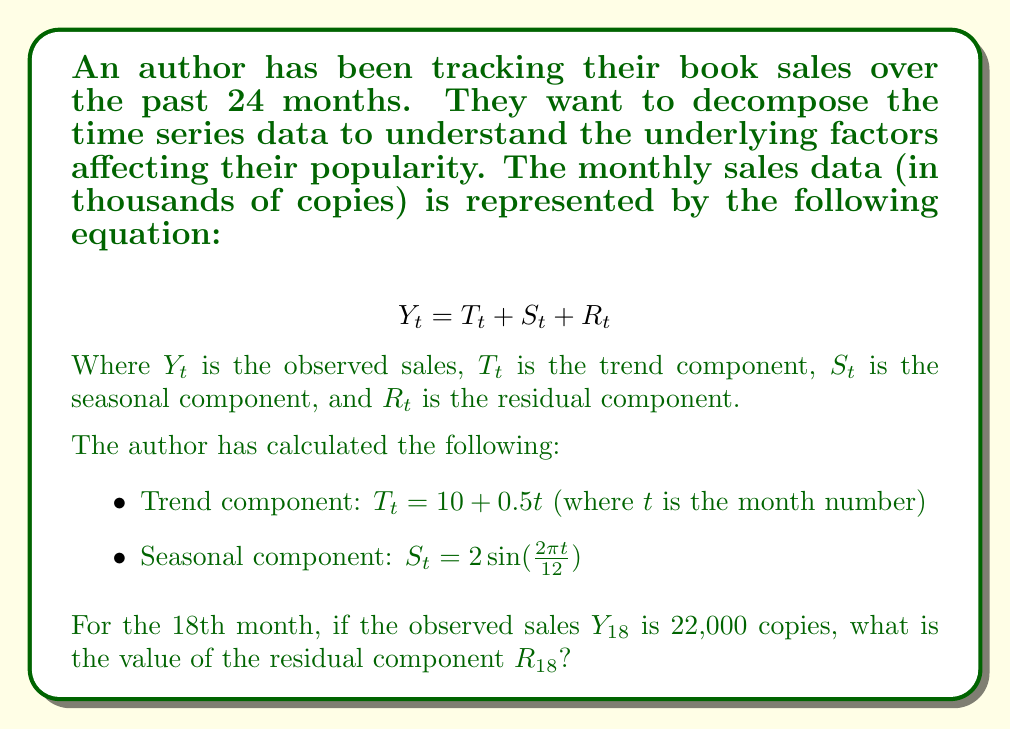Give your solution to this math problem. To solve this problem, we need to follow these steps:

1. Calculate the trend component $T_{18}$ for the 18th month:
   $T_{18} = 10 + 0.5(18) = 10 + 9 = 19$

2. Calculate the seasonal component $S_{18}$ for the 18th month:
   $S_{18} = 2\sin(\frac{2\pi (18)}{12}) = 2\sin(3\pi) = 0$

3. Use the decomposition equation to find the residual component:
   $Y_t = T_t + S_t + R_t$
   $R_t = Y_t - T_t - S_t$

4. Substitute the known values:
   $R_{18} = Y_{18} - T_{18} - S_{18}$
   $R_{18} = 22 - 19 - 0 = 3$

Therefore, the residual component for the 18th month is 3,000 copies.

This residual represents the unexplained variation in sales that month, which could be due to factors like marketing campaigns, book reviews, or other external events that affected the author's popularity.
Answer: $R_{18} = 3$ (thousand copies) 